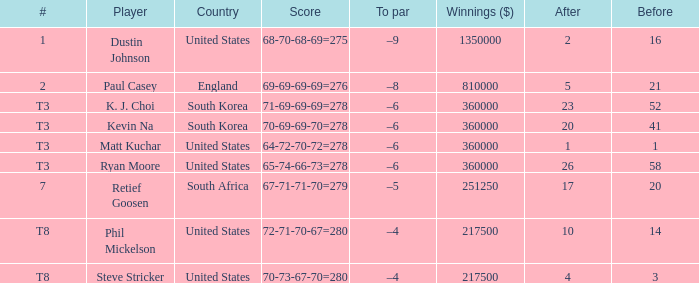What is the # listed when the score is 70-69-69-70=278? T3. 